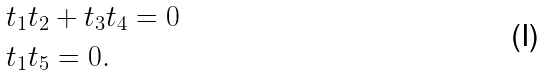<formula> <loc_0><loc_0><loc_500><loc_500>& t _ { 1 } t _ { 2 } + t _ { 3 } t _ { 4 } = 0 \\ & t _ { 1 } t _ { 5 } = 0 .</formula> 